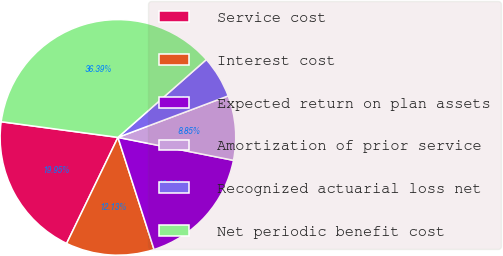Convert chart to OTSL. <chart><loc_0><loc_0><loc_500><loc_500><pie_chart><fcel>Service cost<fcel>Interest cost<fcel>Expected return on plan assets<fcel>Amortization of prior service<fcel>Recognized actuarial loss net<fcel>Net periodic benefit cost<nl><fcel>19.95%<fcel>12.13%<fcel>16.92%<fcel>8.85%<fcel>5.76%<fcel>36.39%<nl></chart> 